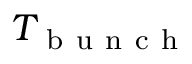Convert formula to latex. <formula><loc_0><loc_0><loc_500><loc_500>T _ { b u n c h }</formula> 